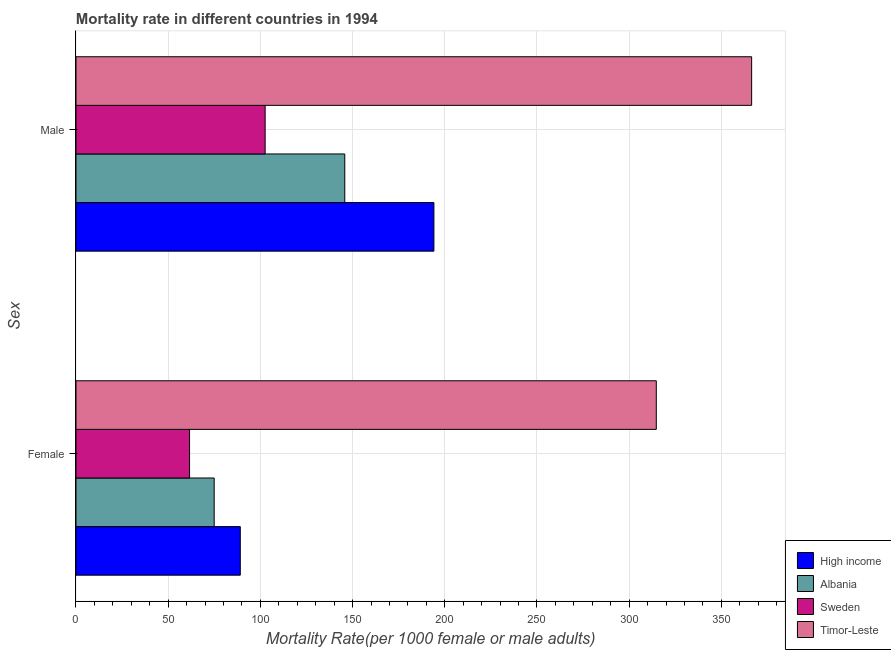How many different coloured bars are there?
Give a very brief answer. 4. Are the number of bars per tick equal to the number of legend labels?
Provide a succinct answer. Yes. Are the number of bars on each tick of the Y-axis equal?
Give a very brief answer. Yes. How many bars are there on the 2nd tick from the bottom?
Your response must be concise. 4. What is the male mortality rate in Sweden?
Your response must be concise. 102.59. Across all countries, what is the maximum female mortality rate?
Provide a short and direct response. 314.72. Across all countries, what is the minimum male mortality rate?
Offer a terse response. 102.59. In which country was the female mortality rate maximum?
Provide a short and direct response. Timor-Leste. In which country was the female mortality rate minimum?
Your answer should be compact. Sweden. What is the total male mortality rate in the graph?
Give a very brief answer. 808.91. What is the difference between the female mortality rate in Timor-Leste and that in Albania?
Provide a short and direct response. 239.77. What is the difference between the male mortality rate in High income and the female mortality rate in Sweden?
Make the answer very short. 132.52. What is the average male mortality rate per country?
Your answer should be very brief. 202.23. What is the difference between the male mortality rate and female mortality rate in High income?
Make the answer very short. 105.01. In how many countries, is the female mortality rate greater than 260 ?
Provide a short and direct response. 1. What is the ratio of the male mortality rate in Albania to that in High income?
Your answer should be compact. 0.75. In how many countries, is the male mortality rate greater than the average male mortality rate taken over all countries?
Your response must be concise. 1. What does the 3rd bar from the top in Female represents?
Offer a terse response. Albania. What does the 2nd bar from the bottom in Male represents?
Keep it short and to the point. Albania. How many bars are there?
Keep it short and to the point. 8. Are all the bars in the graph horizontal?
Your response must be concise. Yes. What is the difference between two consecutive major ticks on the X-axis?
Your response must be concise. 50. Are the values on the major ticks of X-axis written in scientific E-notation?
Provide a short and direct response. No. Does the graph contain grids?
Your response must be concise. Yes. Where does the legend appear in the graph?
Make the answer very short. Bottom right. What is the title of the graph?
Offer a terse response. Mortality rate in different countries in 1994. Does "Jamaica" appear as one of the legend labels in the graph?
Keep it short and to the point. No. What is the label or title of the X-axis?
Offer a very short reply. Mortality Rate(per 1000 female or male adults). What is the label or title of the Y-axis?
Your answer should be compact. Sex. What is the Mortality Rate(per 1000 female or male adults) in High income in Female?
Provide a short and direct response. 89.11. What is the Mortality Rate(per 1000 female or male adults) of Albania in Female?
Your answer should be very brief. 74.95. What is the Mortality Rate(per 1000 female or male adults) of Sweden in Female?
Provide a short and direct response. 61.59. What is the Mortality Rate(per 1000 female or male adults) of Timor-Leste in Female?
Your answer should be compact. 314.72. What is the Mortality Rate(per 1000 female or male adults) of High income in Male?
Give a very brief answer. 194.11. What is the Mortality Rate(per 1000 female or male adults) in Albania in Male?
Offer a very short reply. 145.77. What is the Mortality Rate(per 1000 female or male adults) in Sweden in Male?
Offer a terse response. 102.59. What is the Mortality Rate(per 1000 female or male adults) in Timor-Leste in Male?
Make the answer very short. 366.44. Across all Sex, what is the maximum Mortality Rate(per 1000 female or male adults) in High income?
Give a very brief answer. 194.11. Across all Sex, what is the maximum Mortality Rate(per 1000 female or male adults) in Albania?
Keep it short and to the point. 145.77. Across all Sex, what is the maximum Mortality Rate(per 1000 female or male adults) of Sweden?
Your answer should be compact. 102.59. Across all Sex, what is the maximum Mortality Rate(per 1000 female or male adults) in Timor-Leste?
Make the answer very short. 366.44. Across all Sex, what is the minimum Mortality Rate(per 1000 female or male adults) in High income?
Keep it short and to the point. 89.11. Across all Sex, what is the minimum Mortality Rate(per 1000 female or male adults) in Albania?
Give a very brief answer. 74.95. Across all Sex, what is the minimum Mortality Rate(per 1000 female or male adults) of Sweden?
Give a very brief answer. 61.59. Across all Sex, what is the minimum Mortality Rate(per 1000 female or male adults) in Timor-Leste?
Provide a succinct answer. 314.72. What is the total Mortality Rate(per 1000 female or male adults) in High income in the graph?
Offer a terse response. 283.22. What is the total Mortality Rate(per 1000 female or male adults) in Albania in the graph?
Your answer should be compact. 220.72. What is the total Mortality Rate(per 1000 female or male adults) in Sweden in the graph?
Give a very brief answer. 164.18. What is the total Mortality Rate(per 1000 female or male adults) of Timor-Leste in the graph?
Your answer should be compact. 681.16. What is the difference between the Mortality Rate(per 1000 female or male adults) in High income in Female and that in Male?
Make the answer very short. -105.01. What is the difference between the Mortality Rate(per 1000 female or male adults) of Albania in Female and that in Male?
Provide a short and direct response. -70.82. What is the difference between the Mortality Rate(per 1000 female or male adults) of Sweden in Female and that in Male?
Offer a very short reply. -40.99. What is the difference between the Mortality Rate(per 1000 female or male adults) of Timor-Leste in Female and that in Male?
Give a very brief answer. -51.71. What is the difference between the Mortality Rate(per 1000 female or male adults) of High income in Female and the Mortality Rate(per 1000 female or male adults) of Albania in Male?
Make the answer very short. -56.66. What is the difference between the Mortality Rate(per 1000 female or male adults) of High income in Female and the Mortality Rate(per 1000 female or male adults) of Sweden in Male?
Provide a short and direct response. -13.48. What is the difference between the Mortality Rate(per 1000 female or male adults) of High income in Female and the Mortality Rate(per 1000 female or male adults) of Timor-Leste in Male?
Your answer should be compact. -277.33. What is the difference between the Mortality Rate(per 1000 female or male adults) of Albania in Female and the Mortality Rate(per 1000 female or male adults) of Sweden in Male?
Your answer should be very brief. -27.64. What is the difference between the Mortality Rate(per 1000 female or male adults) in Albania in Female and the Mortality Rate(per 1000 female or male adults) in Timor-Leste in Male?
Provide a succinct answer. -291.48. What is the difference between the Mortality Rate(per 1000 female or male adults) of Sweden in Female and the Mortality Rate(per 1000 female or male adults) of Timor-Leste in Male?
Keep it short and to the point. -304.84. What is the average Mortality Rate(per 1000 female or male adults) in High income per Sex?
Give a very brief answer. 141.61. What is the average Mortality Rate(per 1000 female or male adults) in Albania per Sex?
Provide a short and direct response. 110.36. What is the average Mortality Rate(per 1000 female or male adults) in Sweden per Sex?
Make the answer very short. 82.09. What is the average Mortality Rate(per 1000 female or male adults) in Timor-Leste per Sex?
Keep it short and to the point. 340.58. What is the difference between the Mortality Rate(per 1000 female or male adults) of High income and Mortality Rate(per 1000 female or male adults) of Albania in Female?
Make the answer very short. 14.16. What is the difference between the Mortality Rate(per 1000 female or male adults) of High income and Mortality Rate(per 1000 female or male adults) of Sweden in Female?
Ensure brevity in your answer.  27.52. What is the difference between the Mortality Rate(per 1000 female or male adults) in High income and Mortality Rate(per 1000 female or male adults) in Timor-Leste in Female?
Keep it short and to the point. -225.62. What is the difference between the Mortality Rate(per 1000 female or male adults) of Albania and Mortality Rate(per 1000 female or male adults) of Sweden in Female?
Your response must be concise. 13.36. What is the difference between the Mortality Rate(per 1000 female or male adults) of Albania and Mortality Rate(per 1000 female or male adults) of Timor-Leste in Female?
Keep it short and to the point. -239.77. What is the difference between the Mortality Rate(per 1000 female or male adults) of Sweden and Mortality Rate(per 1000 female or male adults) of Timor-Leste in Female?
Your answer should be compact. -253.13. What is the difference between the Mortality Rate(per 1000 female or male adults) in High income and Mortality Rate(per 1000 female or male adults) in Albania in Male?
Offer a terse response. 48.34. What is the difference between the Mortality Rate(per 1000 female or male adults) in High income and Mortality Rate(per 1000 female or male adults) in Sweden in Male?
Your answer should be very brief. 91.53. What is the difference between the Mortality Rate(per 1000 female or male adults) in High income and Mortality Rate(per 1000 female or male adults) in Timor-Leste in Male?
Provide a succinct answer. -172.32. What is the difference between the Mortality Rate(per 1000 female or male adults) of Albania and Mortality Rate(per 1000 female or male adults) of Sweden in Male?
Ensure brevity in your answer.  43.19. What is the difference between the Mortality Rate(per 1000 female or male adults) in Albania and Mortality Rate(per 1000 female or male adults) in Timor-Leste in Male?
Provide a short and direct response. -220.66. What is the difference between the Mortality Rate(per 1000 female or male adults) in Sweden and Mortality Rate(per 1000 female or male adults) in Timor-Leste in Male?
Your response must be concise. -263.85. What is the ratio of the Mortality Rate(per 1000 female or male adults) of High income in Female to that in Male?
Make the answer very short. 0.46. What is the ratio of the Mortality Rate(per 1000 female or male adults) in Albania in Female to that in Male?
Make the answer very short. 0.51. What is the ratio of the Mortality Rate(per 1000 female or male adults) in Sweden in Female to that in Male?
Your answer should be compact. 0.6. What is the ratio of the Mortality Rate(per 1000 female or male adults) in Timor-Leste in Female to that in Male?
Offer a very short reply. 0.86. What is the difference between the highest and the second highest Mortality Rate(per 1000 female or male adults) in High income?
Ensure brevity in your answer.  105.01. What is the difference between the highest and the second highest Mortality Rate(per 1000 female or male adults) of Albania?
Your answer should be compact. 70.82. What is the difference between the highest and the second highest Mortality Rate(per 1000 female or male adults) in Sweden?
Provide a succinct answer. 40.99. What is the difference between the highest and the second highest Mortality Rate(per 1000 female or male adults) in Timor-Leste?
Offer a very short reply. 51.71. What is the difference between the highest and the lowest Mortality Rate(per 1000 female or male adults) of High income?
Offer a very short reply. 105.01. What is the difference between the highest and the lowest Mortality Rate(per 1000 female or male adults) of Albania?
Ensure brevity in your answer.  70.82. What is the difference between the highest and the lowest Mortality Rate(per 1000 female or male adults) of Sweden?
Your answer should be compact. 40.99. What is the difference between the highest and the lowest Mortality Rate(per 1000 female or male adults) in Timor-Leste?
Keep it short and to the point. 51.71. 